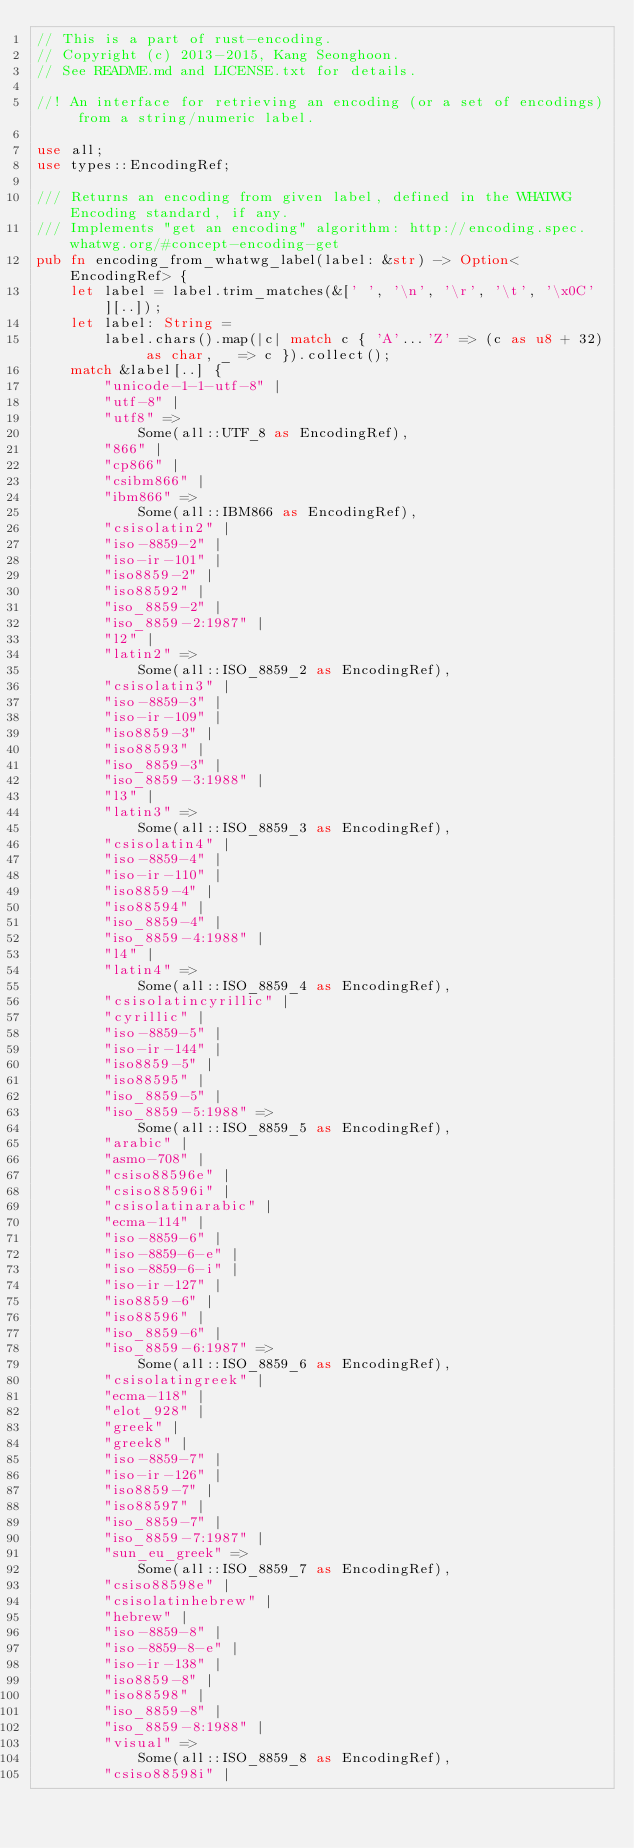Convert code to text. <code><loc_0><loc_0><loc_500><loc_500><_Rust_>// This is a part of rust-encoding.
// Copyright (c) 2013-2015, Kang Seonghoon.
// See README.md and LICENSE.txt for details.

//! An interface for retrieving an encoding (or a set of encodings) from a string/numeric label.

use all;
use types::EncodingRef;

/// Returns an encoding from given label, defined in the WHATWG Encoding standard, if any.
/// Implements "get an encoding" algorithm: http://encoding.spec.whatwg.org/#concept-encoding-get
pub fn encoding_from_whatwg_label(label: &str) -> Option<EncodingRef> {
    let label = label.trim_matches(&[' ', '\n', '\r', '\t', '\x0C'][..]);
    let label: String =
        label.chars().map(|c| match c { 'A'...'Z' => (c as u8 + 32) as char, _ => c }).collect();
    match &label[..] {
        "unicode-1-1-utf-8" |
        "utf-8" |
        "utf8" =>
            Some(all::UTF_8 as EncodingRef),
        "866" |
        "cp866" |
        "csibm866" |
        "ibm866" =>
            Some(all::IBM866 as EncodingRef),
        "csisolatin2" |
        "iso-8859-2" |
        "iso-ir-101" |
        "iso8859-2" |
        "iso88592" |
        "iso_8859-2" |
        "iso_8859-2:1987" |
        "l2" |
        "latin2" =>
            Some(all::ISO_8859_2 as EncodingRef),
        "csisolatin3" |
        "iso-8859-3" |
        "iso-ir-109" |
        "iso8859-3" |
        "iso88593" |
        "iso_8859-3" |
        "iso_8859-3:1988" |
        "l3" |
        "latin3" =>
            Some(all::ISO_8859_3 as EncodingRef),
        "csisolatin4" |
        "iso-8859-4" |
        "iso-ir-110" |
        "iso8859-4" |
        "iso88594" |
        "iso_8859-4" |
        "iso_8859-4:1988" |
        "l4" |
        "latin4" =>
            Some(all::ISO_8859_4 as EncodingRef),
        "csisolatincyrillic" |
        "cyrillic" |
        "iso-8859-5" |
        "iso-ir-144" |
        "iso8859-5" |
        "iso88595" |
        "iso_8859-5" |
        "iso_8859-5:1988" =>
            Some(all::ISO_8859_5 as EncodingRef),
        "arabic" |
        "asmo-708" |
        "csiso88596e" |
        "csiso88596i" |
        "csisolatinarabic" |
        "ecma-114" |
        "iso-8859-6" |
        "iso-8859-6-e" |
        "iso-8859-6-i" |
        "iso-ir-127" |
        "iso8859-6" |
        "iso88596" |
        "iso_8859-6" |
        "iso_8859-6:1987" =>
            Some(all::ISO_8859_6 as EncodingRef),
        "csisolatingreek" |
        "ecma-118" |
        "elot_928" |
        "greek" |
        "greek8" |
        "iso-8859-7" |
        "iso-ir-126" |
        "iso8859-7" |
        "iso88597" |
        "iso_8859-7" |
        "iso_8859-7:1987" |
        "sun_eu_greek" =>
            Some(all::ISO_8859_7 as EncodingRef),
        "csiso88598e" |
        "csisolatinhebrew" |
        "hebrew" |
        "iso-8859-8" |
        "iso-8859-8-e" |
        "iso-ir-138" |
        "iso8859-8" |
        "iso88598" |
        "iso_8859-8" |
        "iso_8859-8:1988" |
        "visual" =>
            Some(all::ISO_8859_8 as EncodingRef),
        "csiso88598i" |</code> 